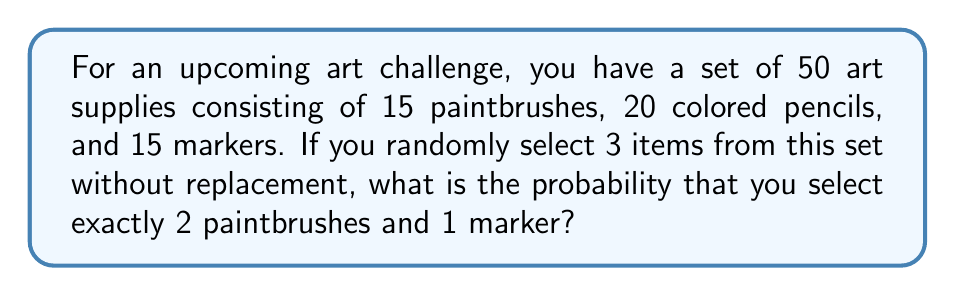Can you solve this math problem? To solve this problem, we'll use the concept of probability and combinations. Let's break it down step-by-step:

1) First, we need to calculate the total number of ways to select 3 items from 50 supplies:
   $$\binom{50}{3} = \frac{50!}{3!(50-3)!} = \frac{50!}{3!47!} = 19,600$$

2) Now, we need to calculate the number of ways to select 2 paintbrushes out of 15:
   $$\binom{15}{2} = \frac{15!}{2!(15-2)!} = \frac{15!}{2!13!} = 105$$

3) We also need to calculate the number of ways to select 1 marker out of 15:
   $$\binom{15}{1} = \frac{15!}{1!(15-1)!} = \frac{15!}{1!14!} = 15$$

4) The number of favorable outcomes is the product of steps 2 and 3:
   $$105 \times 15 = 1,575$$

5) The probability is the number of favorable outcomes divided by the total number of possible outcomes:
   $$P(\text{2 paintbrushes and 1 marker}) = \frac{1,575}{19,600} = \frac{63}{784} \approx 0.0804$$

Therefore, the probability of selecting exactly 2 paintbrushes and 1 marker when randomly choosing 3 items from the set is $\frac{63}{784}$ or approximately 0.0804 or 8.04%.
Answer: $\frac{63}{784}$ or approximately 0.0804 (8.04%) 